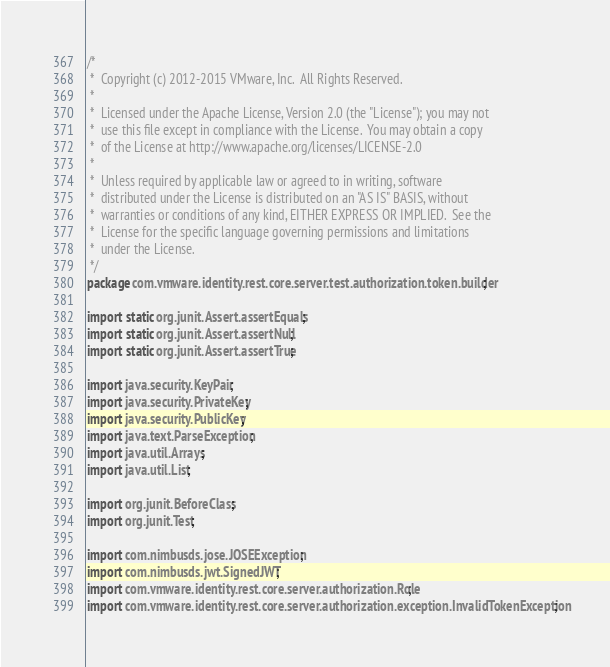Convert code to text. <code><loc_0><loc_0><loc_500><loc_500><_Java_>/*
 *  Copyright (c) 2012-2015 VMware, Inc.  All Rights Reserved.
 *
 *  Licensed under the Apache License, Version 2.0 (the "License"); you may not
 *  use this file except in compliance with the License.  You may obtain a copy
 *  of the License at http://www.apache.org/licenses/LICENSE-2.0
 *
 *  Unless required by applicable law or agreed to in writing, software
 *  distributed under the License is distributed on an "AS IS" BASIS, without
 *  warranties or conditions of any kind, EITHER EXPRESS OR IMPLIED.  See the
 *  License for the specific language governing permissions and limitations
 *  under the License.
 */
package com.vmware.identity.rest.core.server.test.authorization.token.builder;

import static org.junit.Assert.assertEquals;
import static org.junit.Assert.assertNull;
import static org.junit.Assert.assertTrue;

import java.security.KeyPair;
import java.security.PrivateKey;
import java.security.PublicKey;
import java.text.ParseException;
import java.util.Arrays;
import java.util.List;

import org.junit.BeforeClass;
import org.junit.Test;

import com.nimbusds.jose.JOSEException;
import com.nimbusds.jwt.SignedJWT;
import com.vmware.identity.rest.core.server.authorization.Role;
import com.vmware.identity.rest.core.server.authorization.exception.InvalidTokenException;</code> 